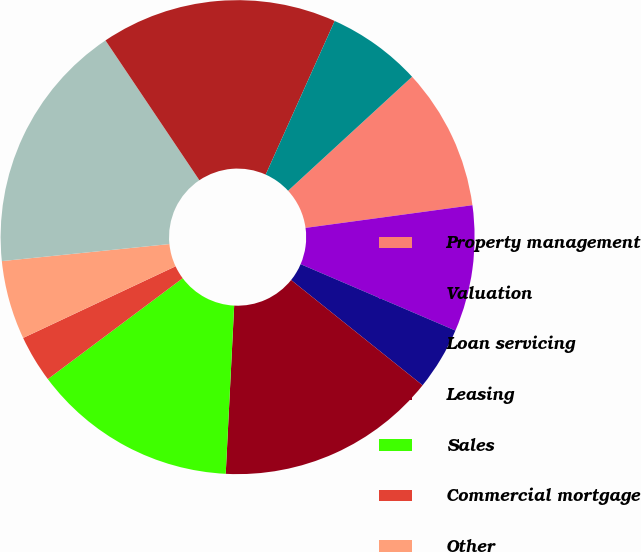Convert chart. <chart><loc_0><loc_0><loc_500><loc_500><pie_chart><fcel>Property management<fcel>Valuation<fcel>Loan servicing<fcel>Leasing<fcel>Sales<fcel>Commercial mortgage<fcel>Other<fcel>Pass through costs also<fcel>Operating administrative and<fcel>Depreciation and amortization<nl><fcel>9.68%<fcel>8.6%<fcel>4.3%<fcel>15.05%<fcel>13.98%<fcel>3.23%<fcel>5.38%<fcel>17.2%<fcel>16.13%<fcel>6.45%<nl></chart> 